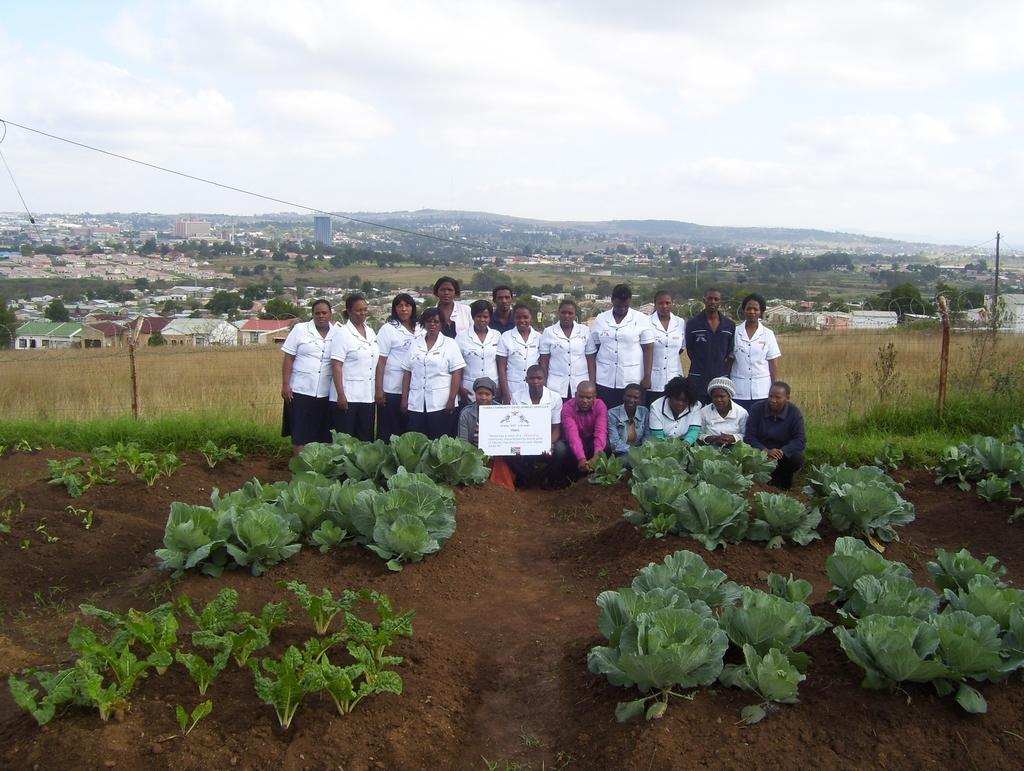What type of vegetation can be seen in the image? There is dry grass and plants in the image. Can you describe the people in the image? There is a group of people in the image. What other natural elements are present in the image? There are trees in the image. What man-made structures can be seen in the image? There are buildings in the image. What part of the natural environment is visible in the image? The sky is visible in the image. How many sacks are being carried by the giants in the image? There are no giants or sacks present in the image. What type of gate can be seen in the image? There is no gate present in the image. 